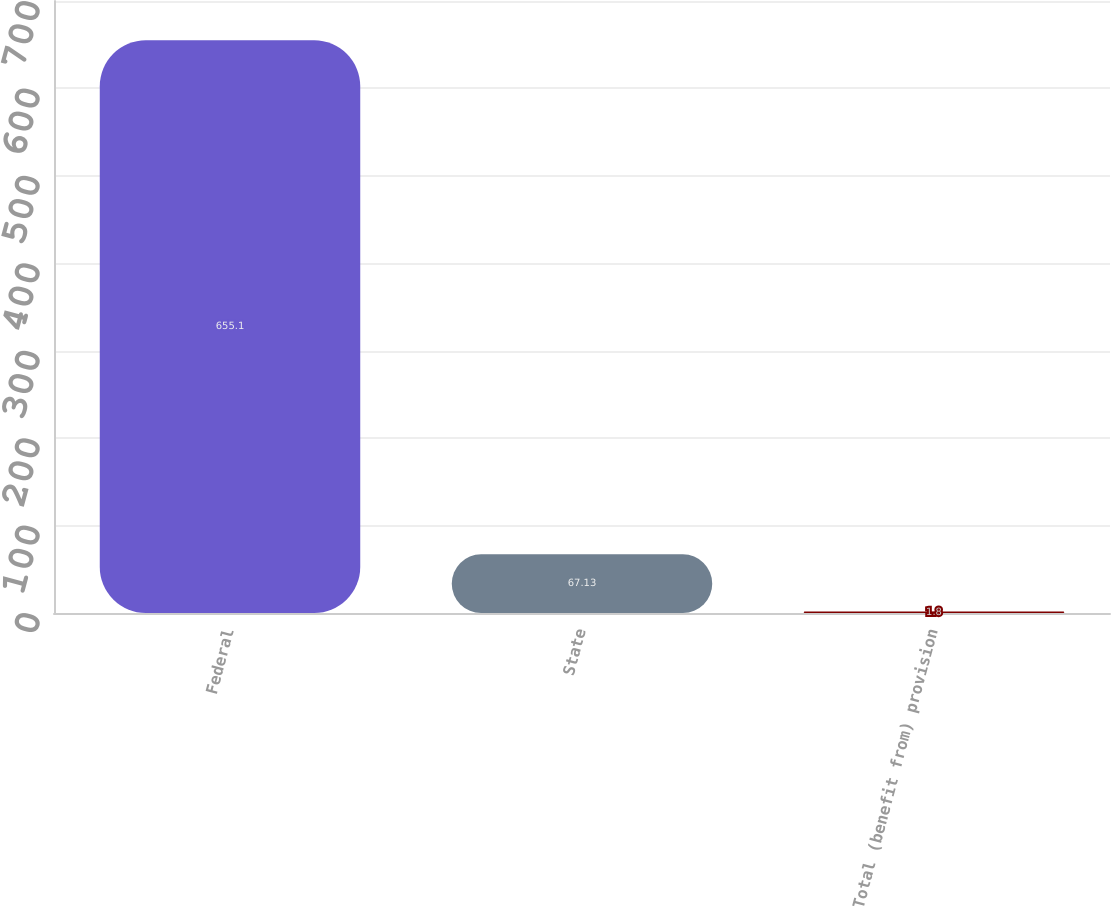Convert chart. <chart><loc_0><loc_0><loc_500><loc_500><bar_chart><fcel>Federal<fcel>State<fcel>Total (benefit from) provision<nl><fcel>655.1<fcel>67.13<fcel>1.8<nl></chart> 